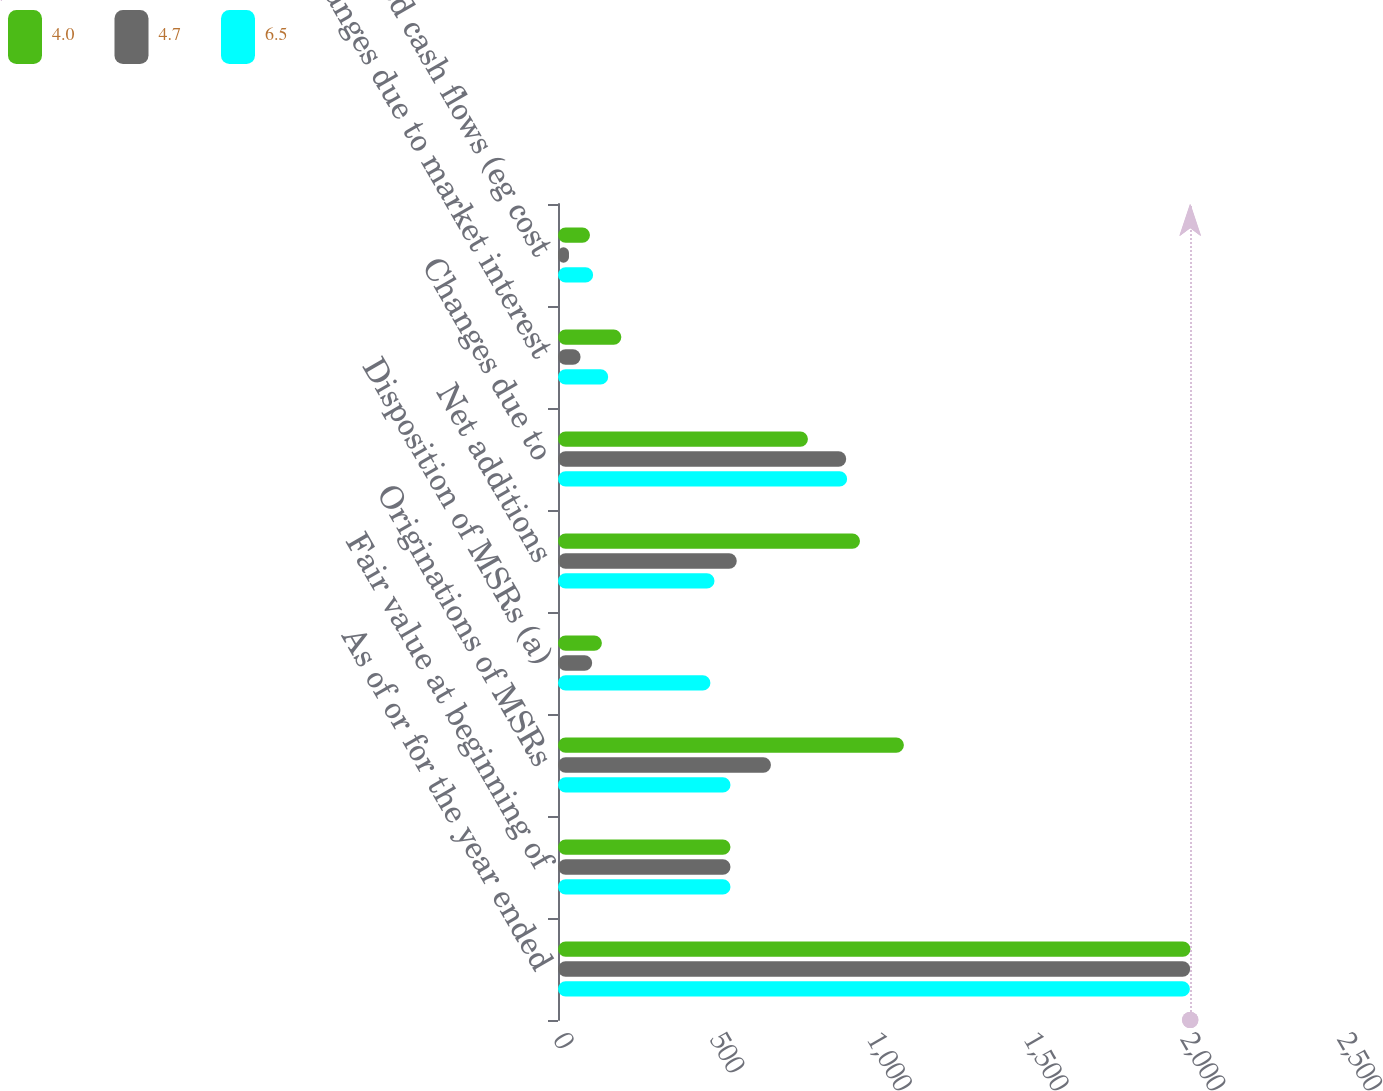Convert chart to OTSL. <chart><loc_0><loc_0><loc_500><loc_500><stacked_bar_chart><ecel><fcel>As of or for the year ended<fcel>Fair value at beginning of<fcel>Originations of MSRs<fcel>Disposition of MSRs (a)<fcel>Net additions<fcel>Changes due to<fcel>Changes due to market interest<fcel>Projected cash flows (eg cost<nl><fcel>4<fcel>2017<fcel>550<fcel>1103<fcel>140<fcel>963<fcel>797<fcel>202<fcel>102<nl><fcel>4.7<fcel>2016<fcel>550<fcel>679<fcel>109<fcel>570<fcel>919<fcel>72<fcel>35<nl><fcel>6.5<fcel>2015<fcel>550<fcel>550<fcel>486<fcel>499<fcel>922<fcel>160<fcel>112<nl></chart> 